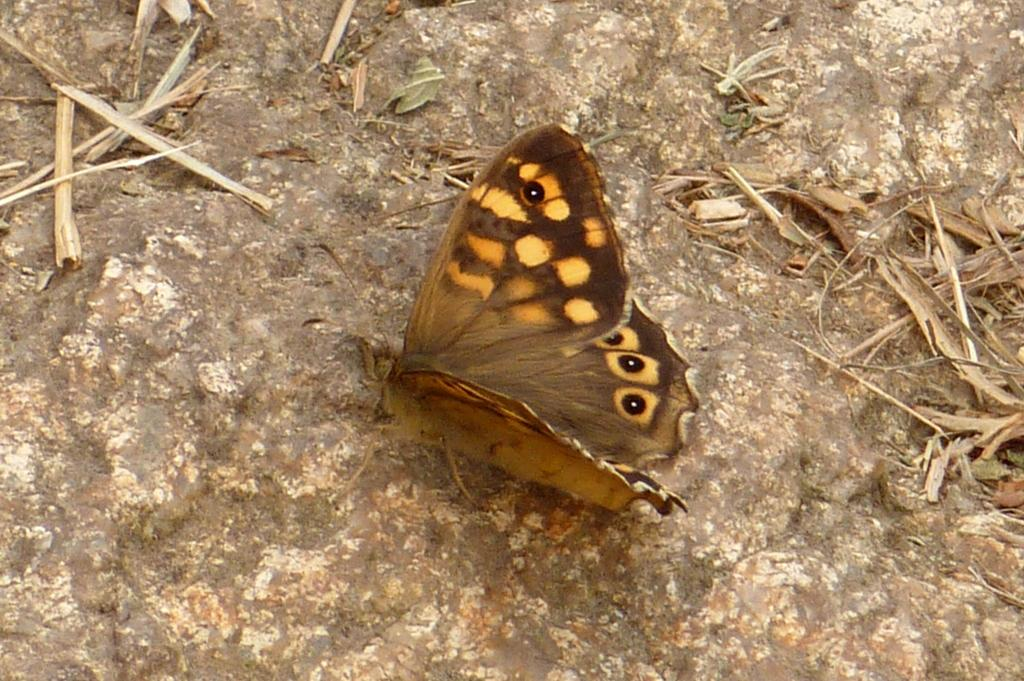What is the main subject of the image? There is a butterfly in the image. Where is the butterfly located? The butterfly is on a rock. What can be seen in the background of the image? There are twigs visible in the background of the image. What type of juice is the butterfly drinking from the rock? There is no juice present in the image, and the butterfly is not shown drinking anything. 